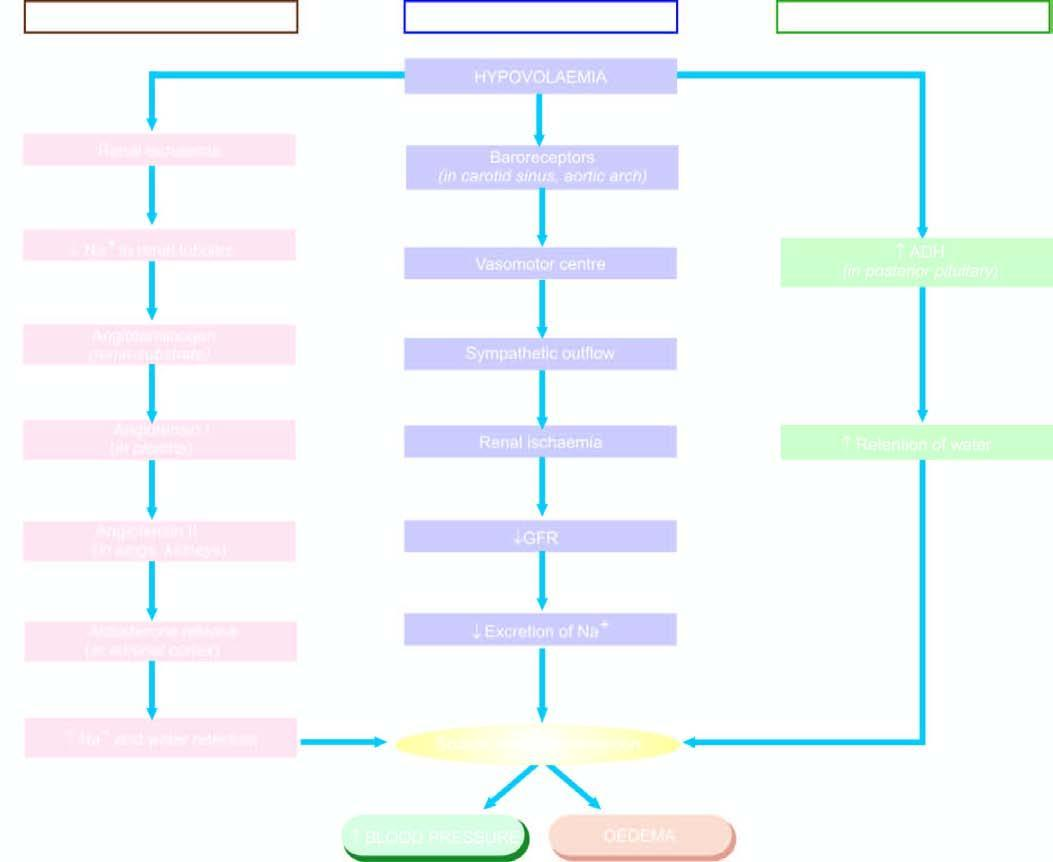s mechanisms involved in oedema by sodium and water retention?
Answer the question using a single word or phrase. Yes 